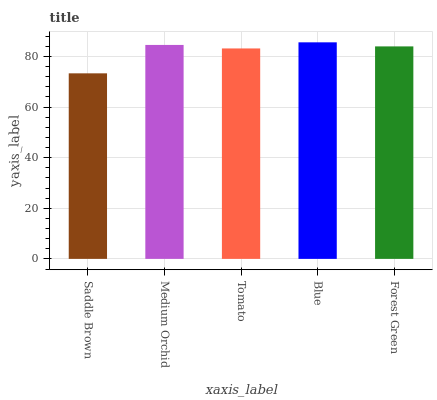Is Medium Orchid the minimum?
Answer yes or no. No. Is Medium Orchid the maximum?
Answer yes or no. No. Is Medium Orchid greater than Saddle Brown?
Answer yes or no. Yes. Is Saddle Brown less than Medium Orchid?
Answer yes or no. Yes. Is Saddle Brown greater than Medium Orchid?
Answer yes or no. No. Is Medium Orchid less than Saddle Brown?
Answer yes or no. No. Is Forest Green the high median?
Answer yes or no. Yes. Is Forest Green the low median?
Answer yes or no. Yes. Is Medium Orchid the high median?
Answer yes or no. No. Is Saddle Brown the low median?
Answer yes or no. No. 